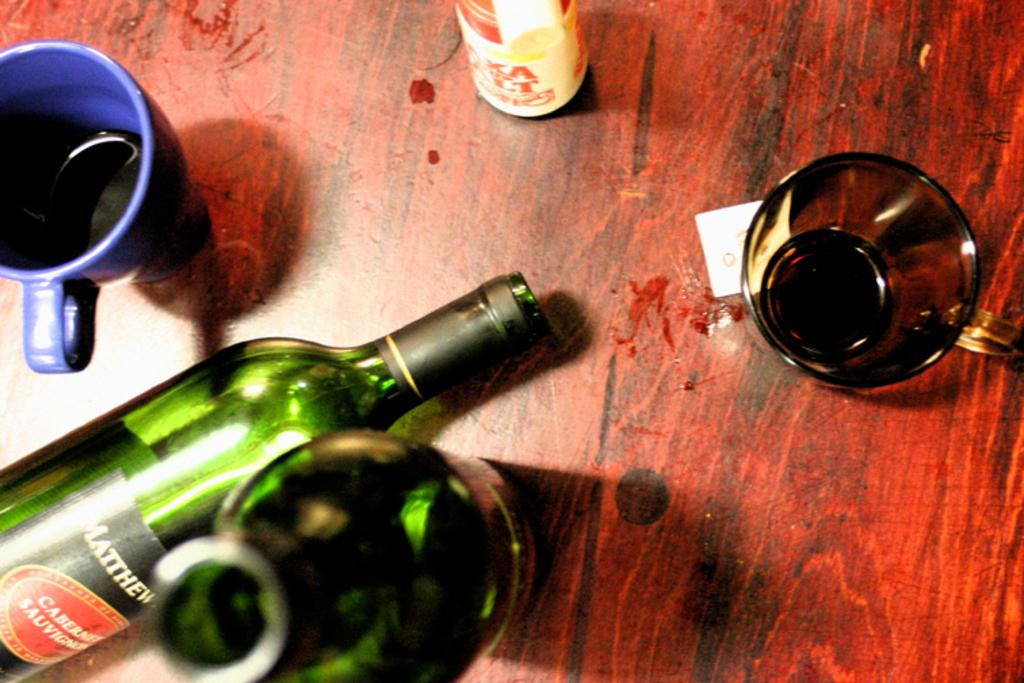What color is the glass on the table in the image? There is a blue glass on the table in the image. What other type of glassware is present on the table? There are green glass bottles on the table. Are there any other glasses on the table besides the blue one? Yes, there is another glass on the table. Can you describe the smell coming from the rat in the image? There is no rat present in the image, so it is not possible to describe any smell associated with it. 